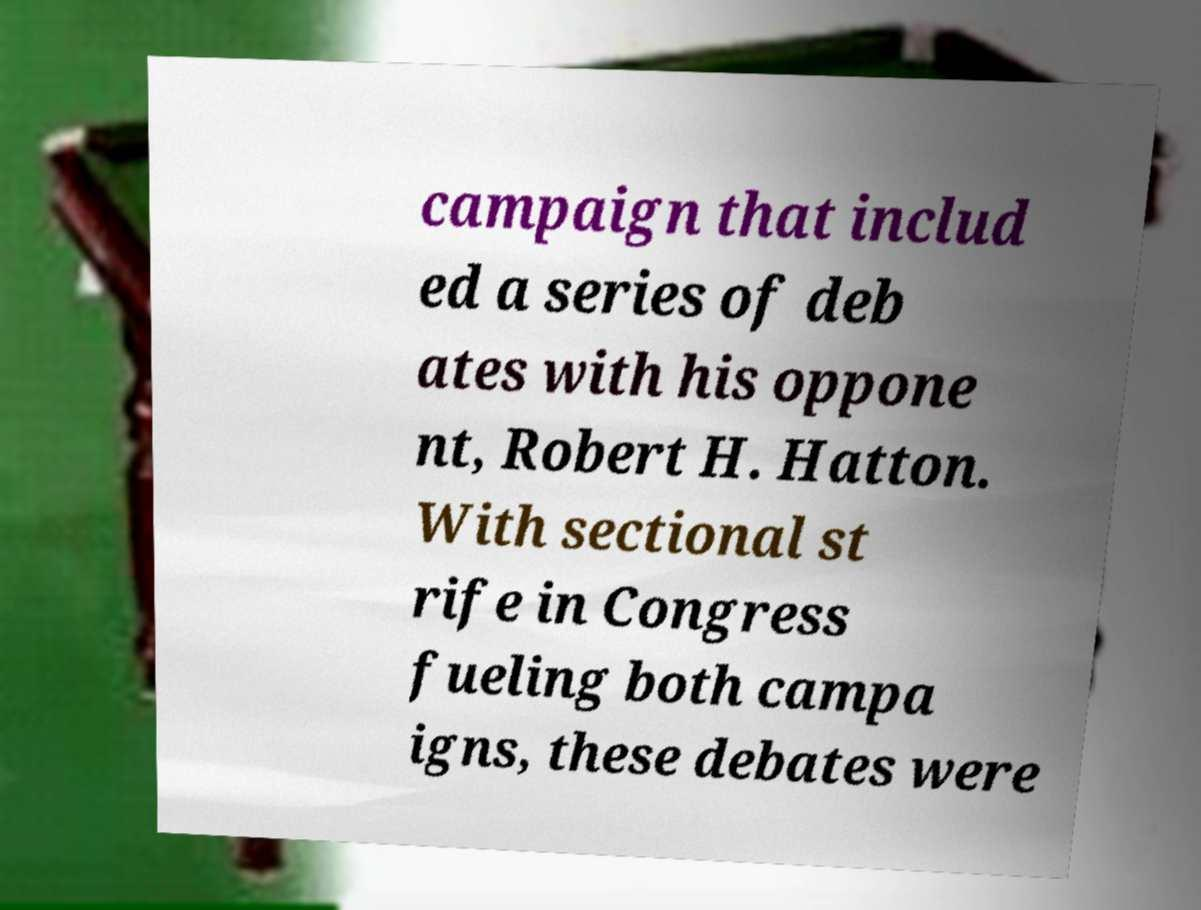What messages or text are displayed in this image? I need them in a readable, typed format. campaign that includ ed a series of deb ates with his oppone nt, Robert H. Hatton. With sectional st rife in Congress fueling both campa igns, these debates were 